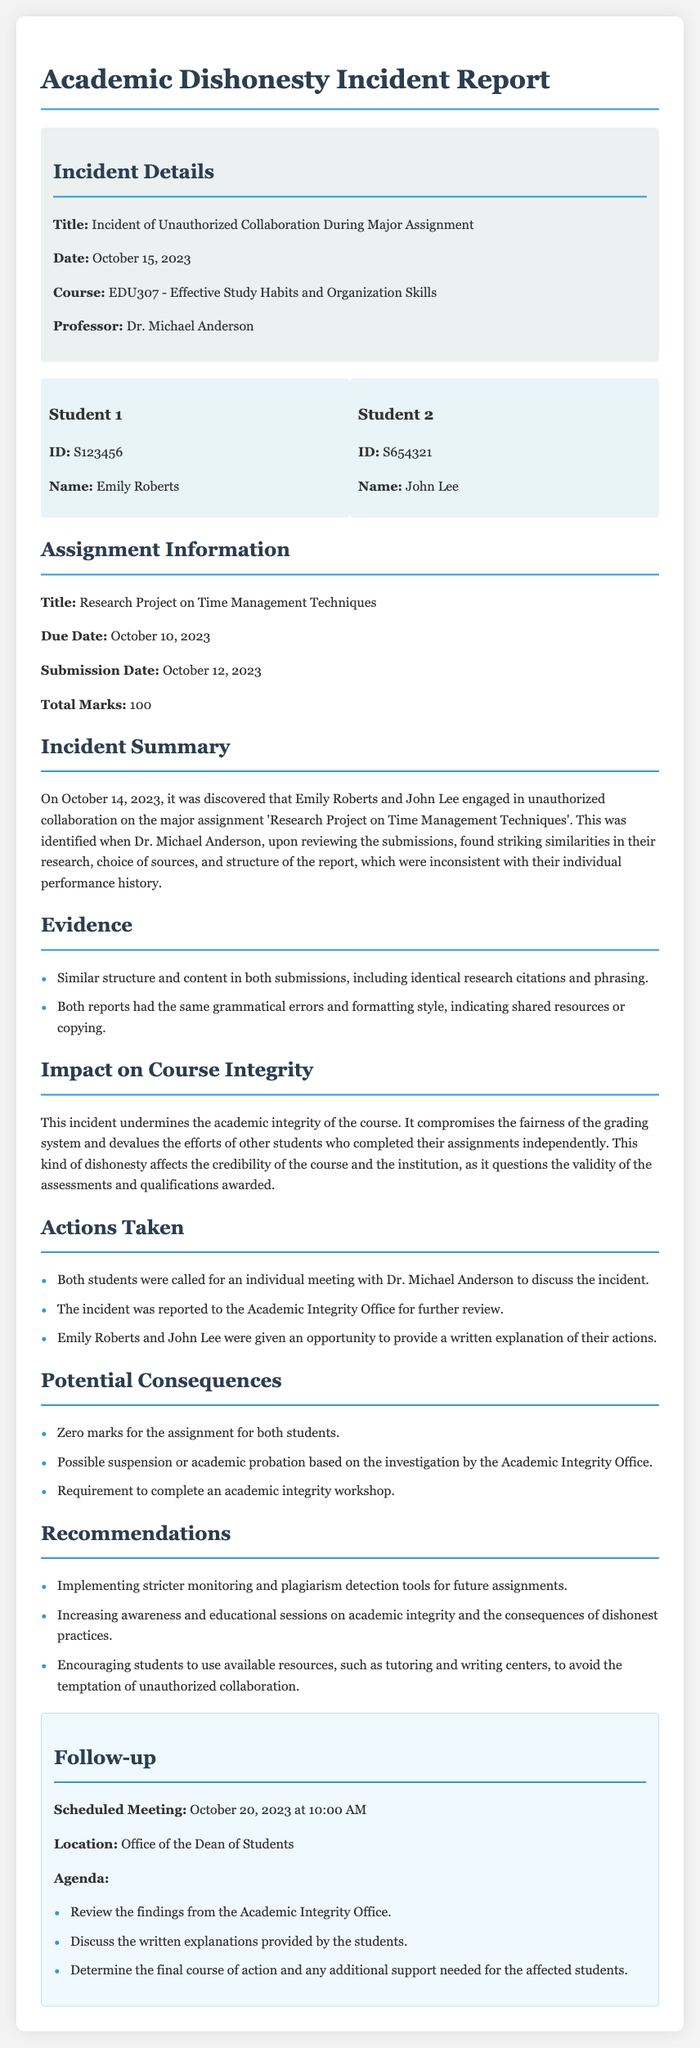What is the title of the incident report? The title of the incident report is found in the incident details section, which states the title as "Incident of Unauthorized Collaboration During Major Assignment."
Answer: Incident of Unauthorized Collaboration During Major Assignment Who are the students involved in the incident? The document lists the names of the students involved in the incident under the student information section, which are Emily Roberts and John Lee.
Answer: Emily Roberts and John Lee What was the due date of the assignment? The due date of the assignment is indicated in the assignment information section, which specifies the due date as October 10, 2023.
Answer: October 10, 2023 What actions were taken regarding the incident? The document outlines actions taken in the actions taken section, which includes meetings with Dr. Michael Anderson and reporting to the Academic Integrity Office.
Answer: Meeting with Dr. Michael Anderson and reporting to the Academic Integrity Office What is the scheduled date for the follow-up meeting? The follow-up meeting date can be found in the follow-up section, which specifies the date as October 20, 2023.
Answer: October 20, 2023 What impact does the incident have on course integrity? The impact on course integrity is described in the impact section, stating that the incident undermines the academic integrity of the course and compromises fairness.
Answer: Undermines the academic integrity of the course What recommendations are made in the report? Recommendations are detailed in the recommendations section, suggesting stricter monitoring and increased awareness of academic integrity.
Answer: Stricter monitoring and increased awareness of academic integrity What is the total marks allocated for the assignment? The total marks for the assignment are mentioned in the assignment information section as 100.
Answer: 100 